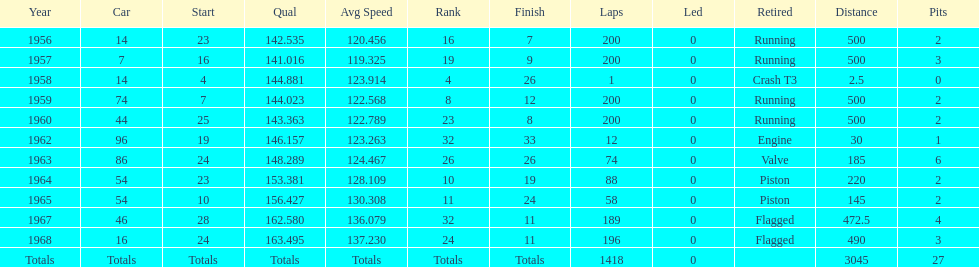What year did he have the same number car as 1964? 1965. 